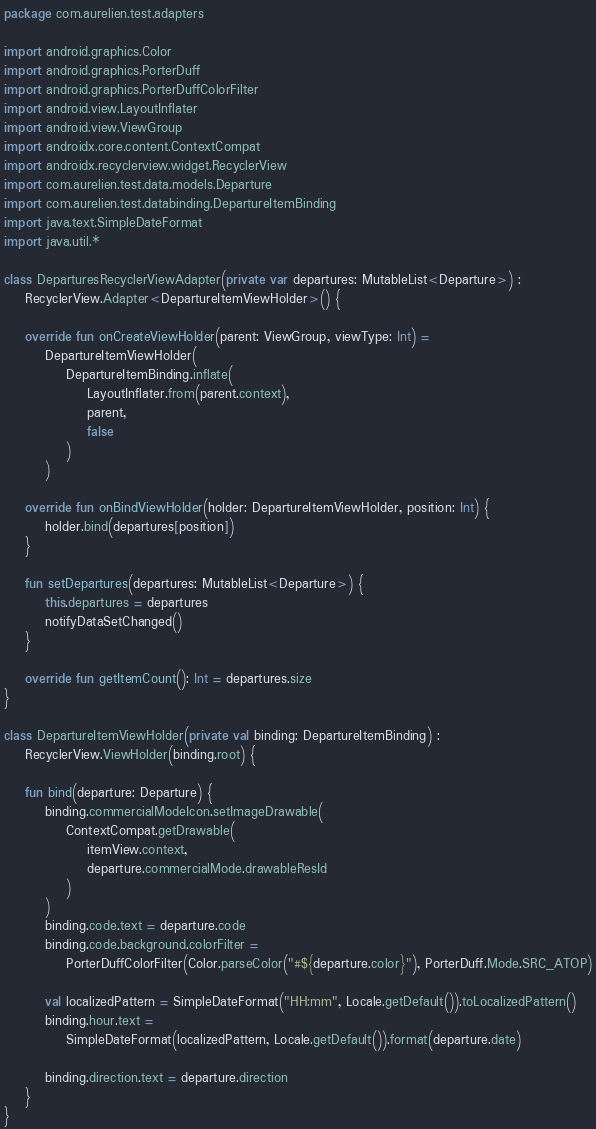<code> <loc_0><loc_0><loc_500><loc_500><_Kotlin_>package com.aurelien.test.adapters

import android.graphics.Color
import android.graphics.PorterDuff
import android.graphics.PorterDuffColorFilter
import android.view.LayoutInflater
import android.view.ViewGroup
import androidx.core.content.ContextCompat
import androidx.recyclerview.widget.RecyclerView
import com.aurelien.test.data.models.Departure
import com.aurelien.test.databinding.DepartureItemBinding
import java.text.SimpleDateFormat
import java.util.*

class DeparturesRecyclerViewAdapter(private var departures: MutableList<Departure>) :
    RecyclerView.Adapter<DepartureItemViewHolder>() {

    override fun onCreateViewHolder(parent: ViewGroup, viewType: Int) =
        DepartureItemViewHolder(
            DepartureItemBinding.inflate(
                LayoutInflater.from(parent.context),
                parent,
                false
            )
        )

    override fun onBindViewHolder(holder: DepartureItemViewHolder, position: Int) {
        holder.bind(departures[position])
    }

    fun setDepartures(departures: MutableList<Departure>) {
        this.departures = departures
        notifyDataSetChanged()
    }

    override fun getItemCount(): Int = departures.size
}

class DepartureItemViewHolder(private val binding: DepartureItemBinding) :
    RecyclerView.ViewHolder(binding.root) {

    fun bind(departure: Departure) {
        binding.commercialModeIcon.setImageDrawable(
            ContextCompat.getDrawable(
                itemView.context,
                departure.commercialMode.drawableResId
            )
        )
        binding.code.text = departure.code
        binding.code.background.colorFilter =
            PorterDuffColorFilter(Color.parseColor("#${departure.color}"), PorterDuff.Mode.SRC_ATOP)

        val localizedPattern = SimpleDateFormat("HH:mm", Locale.getDefault()).toLocalizedPattern()
        binding.hour.text =
            SimpleDateFormat(localizedPattern, Locale.getDefault()).format(departure.date)

        binding.direction.text = departure.direction
    }
}</code> 